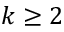Convert formula to latex. <formula><loc_0><loc_0><loc_500><loc_500>k \geq 2</formula> 